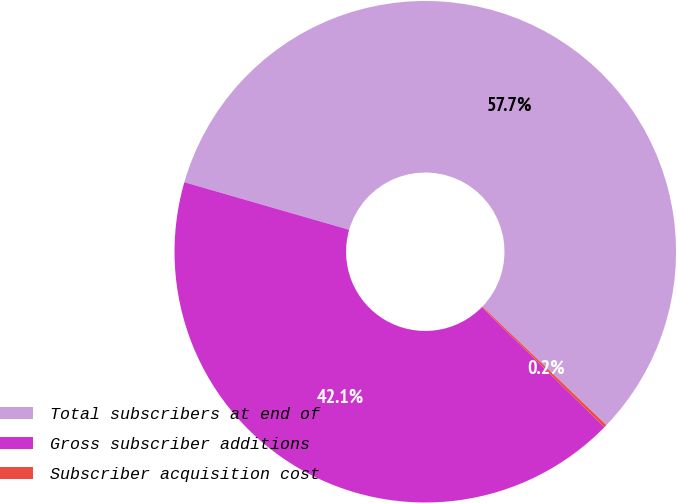<chart> <loc_0><loc_0><loc_500><loc_500><pie_chart><fcel>Total subscribers at end of<fcel>Gross subscriber additions<fcel>Subscriber acquisition cost<nl><fcel>57.68%<fcel>42.14%<fcel>0.18%<nl></chart> 